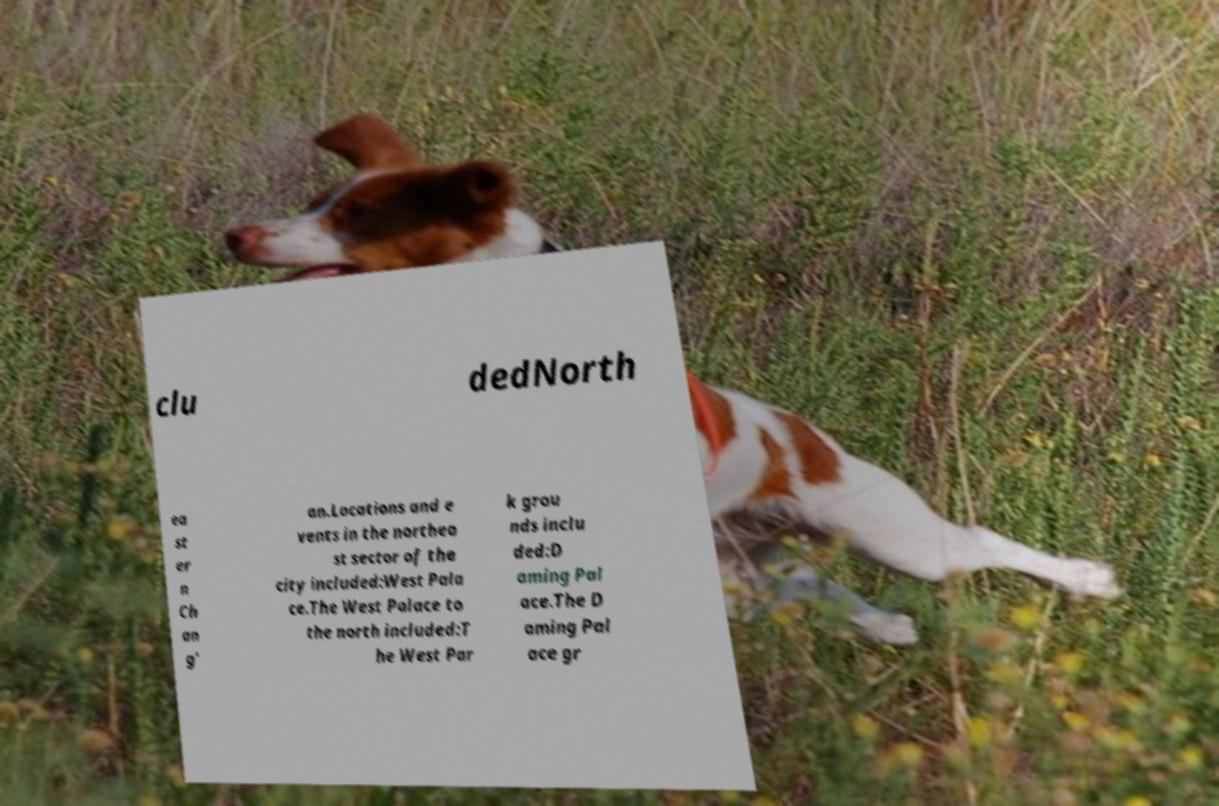For documentation purposes, I need the text within this image transcribed. Could you provide that? clu dedNorth ea st er n Ch an g' an.Locations and e vents in the northea st sector of the city included:West Pala ce.The West Palace to the north included:T he West Par k grou nds inclu ded:D aming Pal ace.The D aming Pal ace gr 